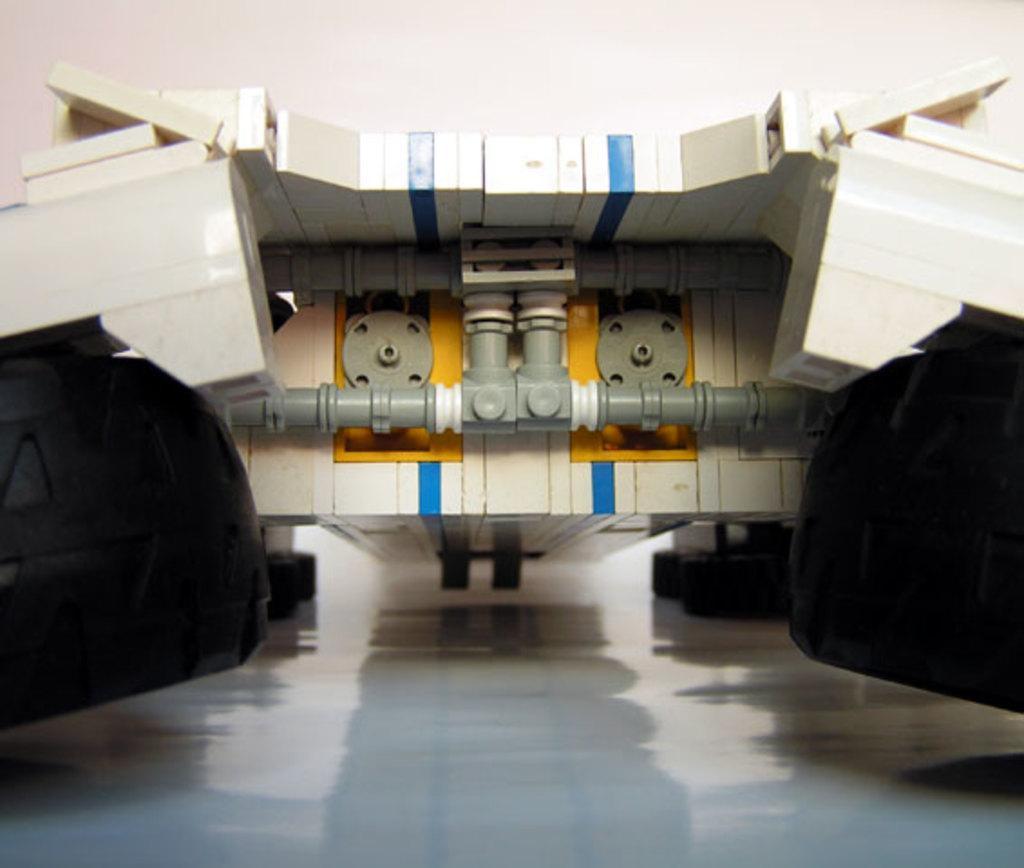Please provide a concise description of this image. In the picture there may be a toy present on the floor. 